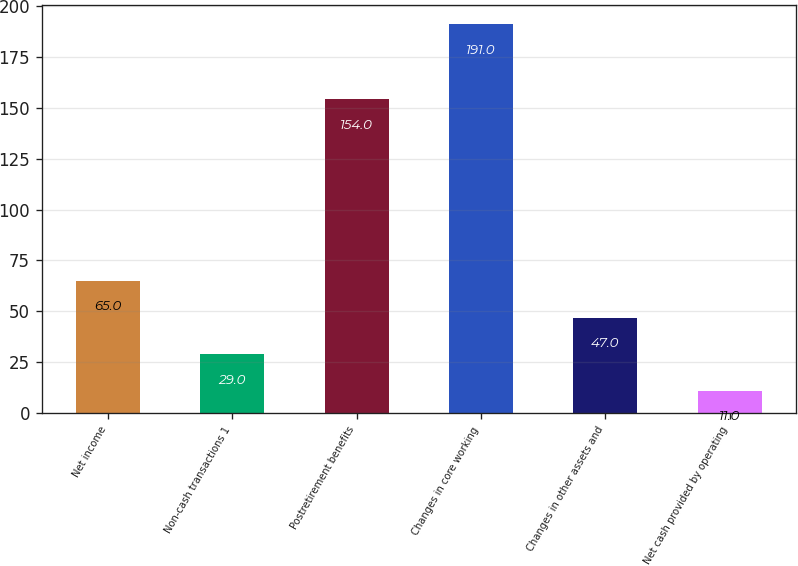<chart> <loc_0><loc_0><loc_500><loc_500><bar_chart><fcel>Net income<fcel>Non-cash transactions 1<fcel>Postretirement benefits<fcel>Changes in core working<fcel>Changes in other assets and<fcel>Net cash provided by operating<nl><fcel>65<fcel>29<fcel>154<fcel>191<fcel>47<fcel>11<nl></chart> 